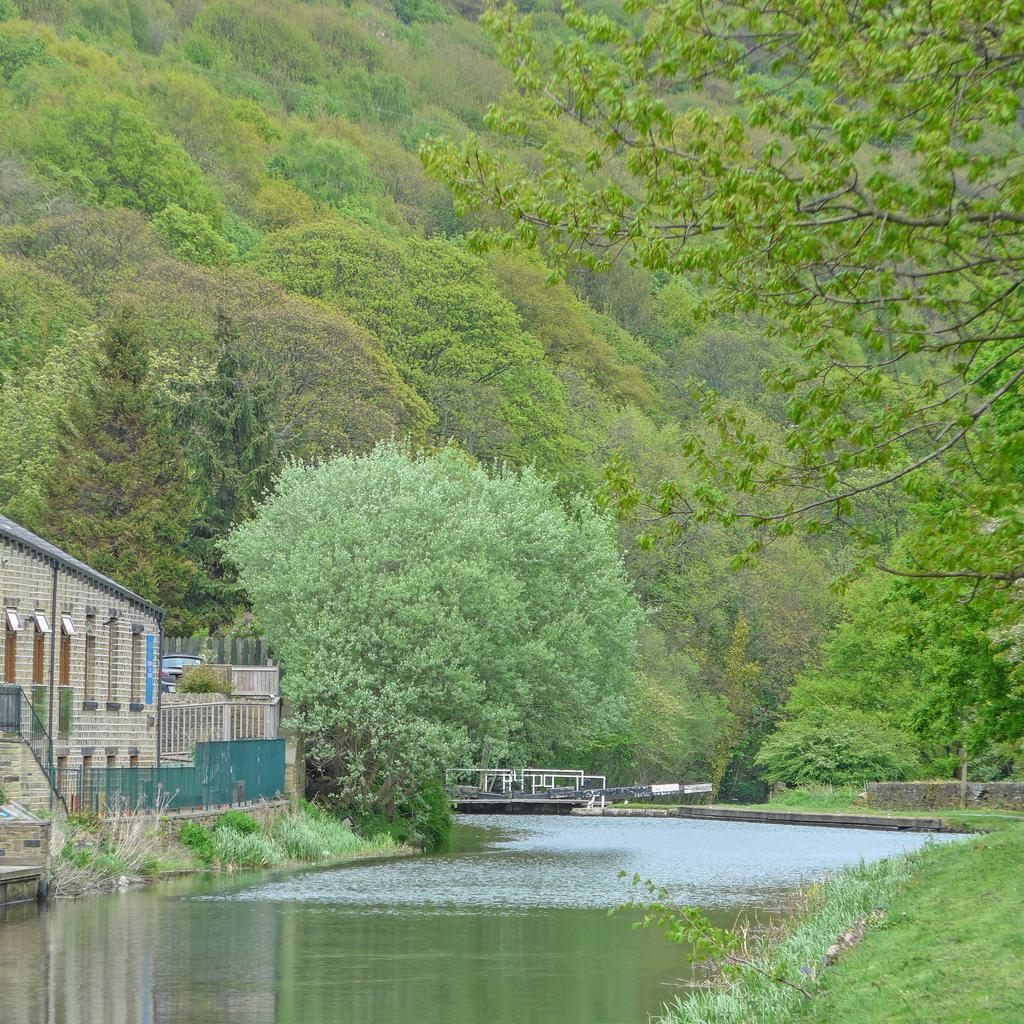Please provide a concise description of this image. In the background we can see the trees. On the left side of the picture we can see a building and the railing. Far it looks like a vehicle. In this picture we can see the water, green grass, plants. In the background we can see the wall and an object. 